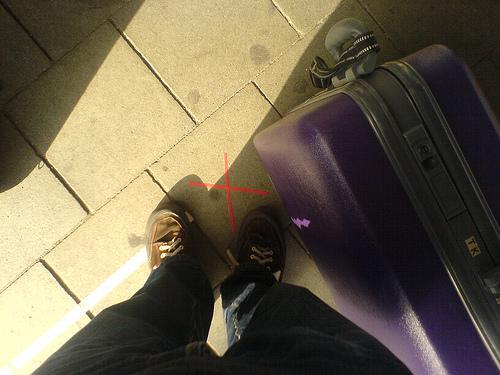Question: what is this?
Choices:
A. Luggage.
B. Box.
C. Package.
D. Bag.
Answer with the letter. Answer: A Question: how is the photo?
Choices:
A. Cloudy.
B. Black and white.
C. Good.
D. Clear.
Answer with the letter. Answer: D Question: what else is visible?
Choices:
A. Sun.
B. Moon.
C. Shoes.
D. Stars.
Answer with the letter. Answer: C Question: why is there a shadow?
Choices:
A. Light.
B. Tree.
C. Dog.
D. Cat.
Answer with the letter. Answer: A Question: who is this?
Choices:
A. Woman.
B. Man.
C. Child.
D. Car.
Answer with the letter. Answer: B Question: where is this scene?
Choices:
A. At the bus station.
B. At the airport.
C. At the train station.
D. At a transportation station.
Answer with the letter. Answer: D 